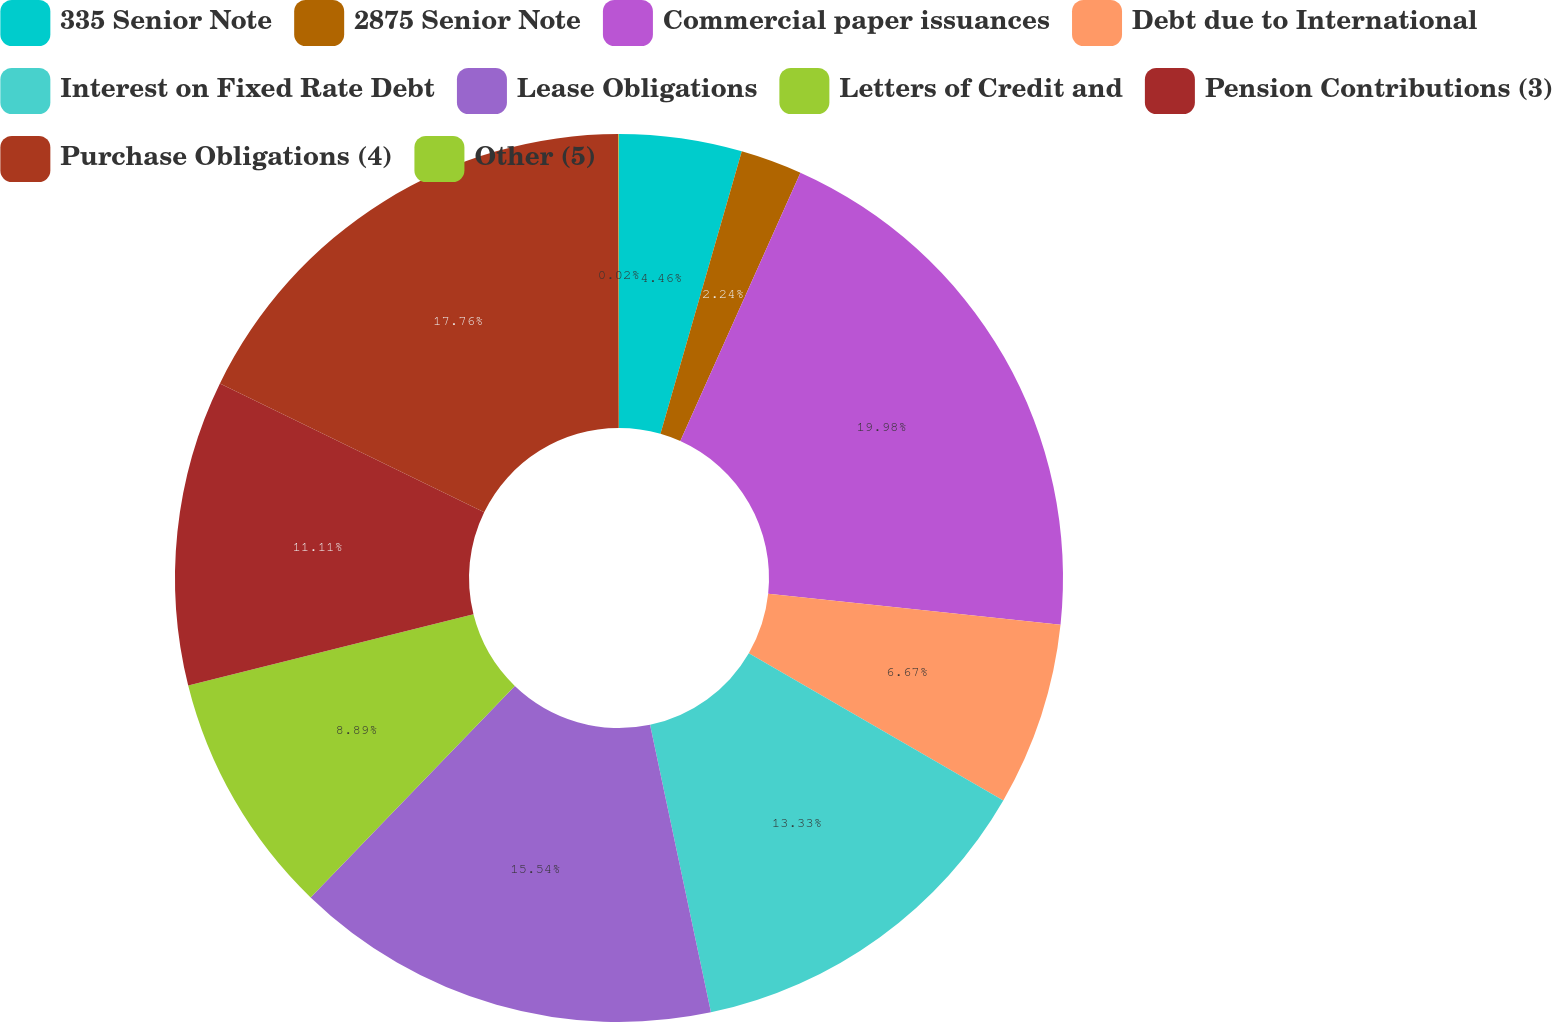<chart> <loc_0><loc_0><loc_500><loc_500><pie_chart><fcel>335 Senior Note<fcel>2875 Senior Note<fcel>Commercial paper issuances<fcel>Debt due to International<fcel>Interest on Fixed Rate Debt<fcel>Lease Obligations<fcel>Letters of Credit and<fcel>Pension Contributions (3)<fcel>Purchase Obligations (4)<fcel>Other (5)<nl><fcel>4.46%<fcel>2.24%<fcel>19.98%<fcel>6.67%<fcel>13.33%<fcel>15.54%<fcel>8.89%<fcel>11.11%<fcel>17.76%<fcel>0.02%<nl></chart> 